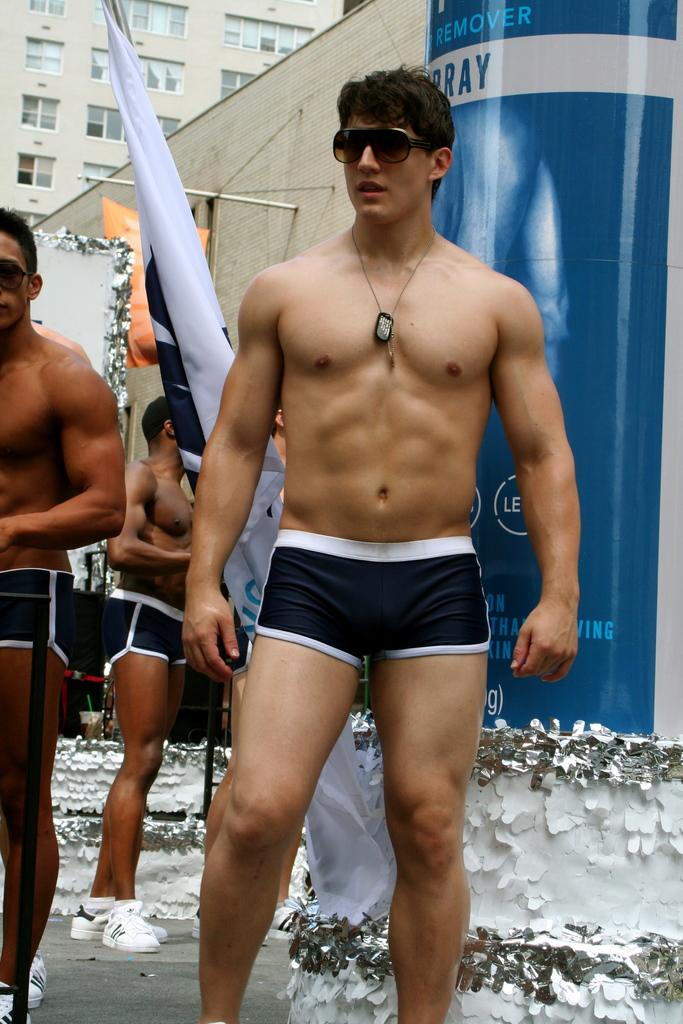What can be seen in the foreground of the image? There are people and a flag in the foreground of the image. What is the nature of the wall in the image? There is a wall in the image, but its specific characteristics are not mentioned. What can be seen in the background of the image? There are other objects and a building in the background of the image. How many women are shown giving their approval in the image? There is no mention of women or approval in the image; it features people and a flag in the foreground, a wall, and a building in the background. 